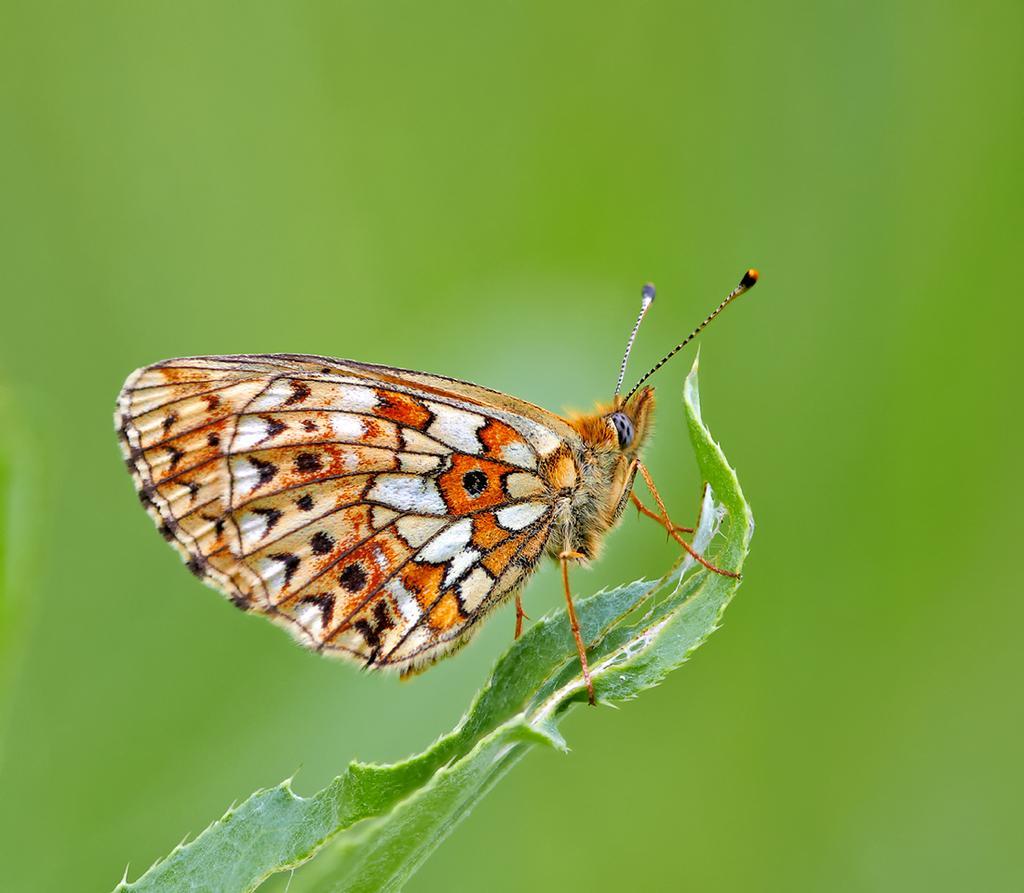Could you give a brief overview of what you see in this image? As we can see in the image in the front there is a leaf. On leaf there is a butterfly and the background is blurred. 